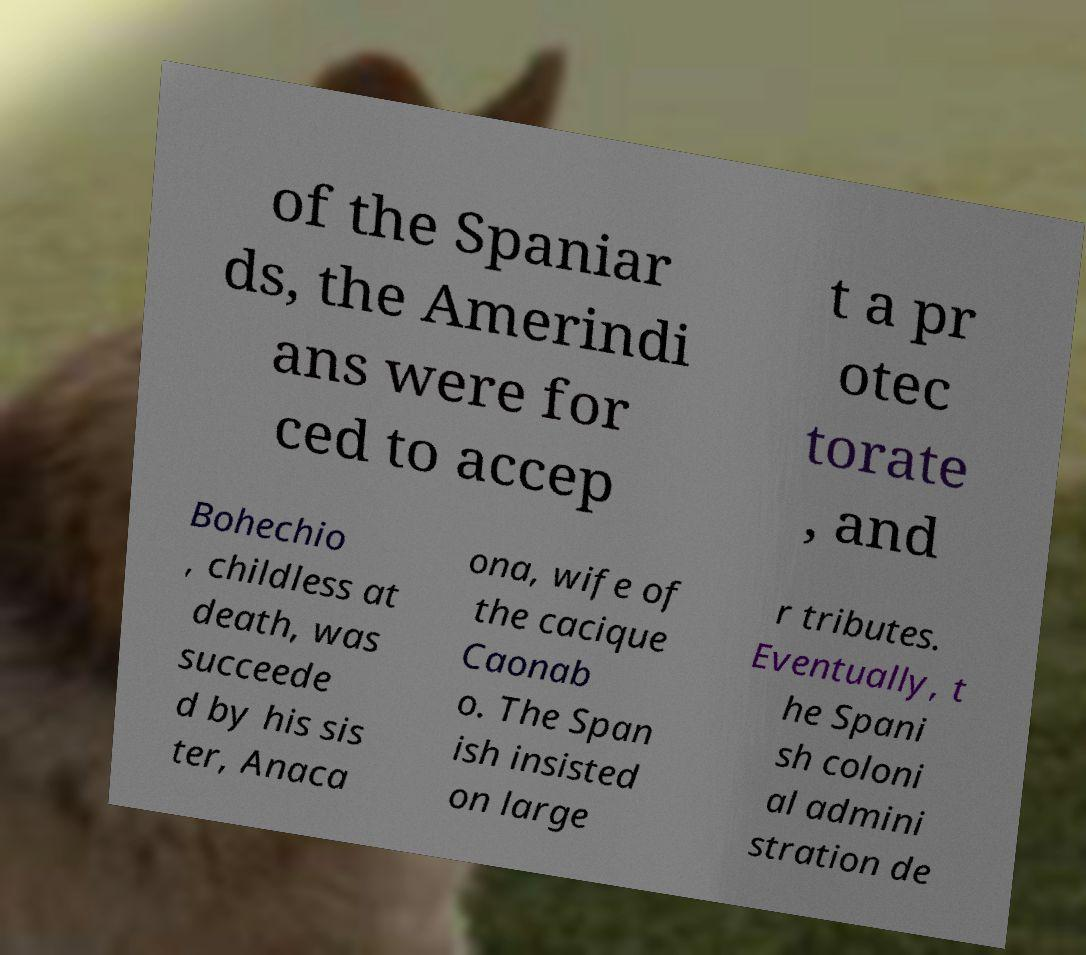For documentation purposes, I need the text within this image transcribed. Could you provide that? of the Spaniar ds, the Amerindi ans were for ced to accep t a pr otec torate , and Bohechio , childless at death, was succeede d by his sis ter, Anaca ona, wife of the cacique Caonab o. The Span ish insisted on large r tributes. Eventually, t he Spani sh coloni al admini stration de 